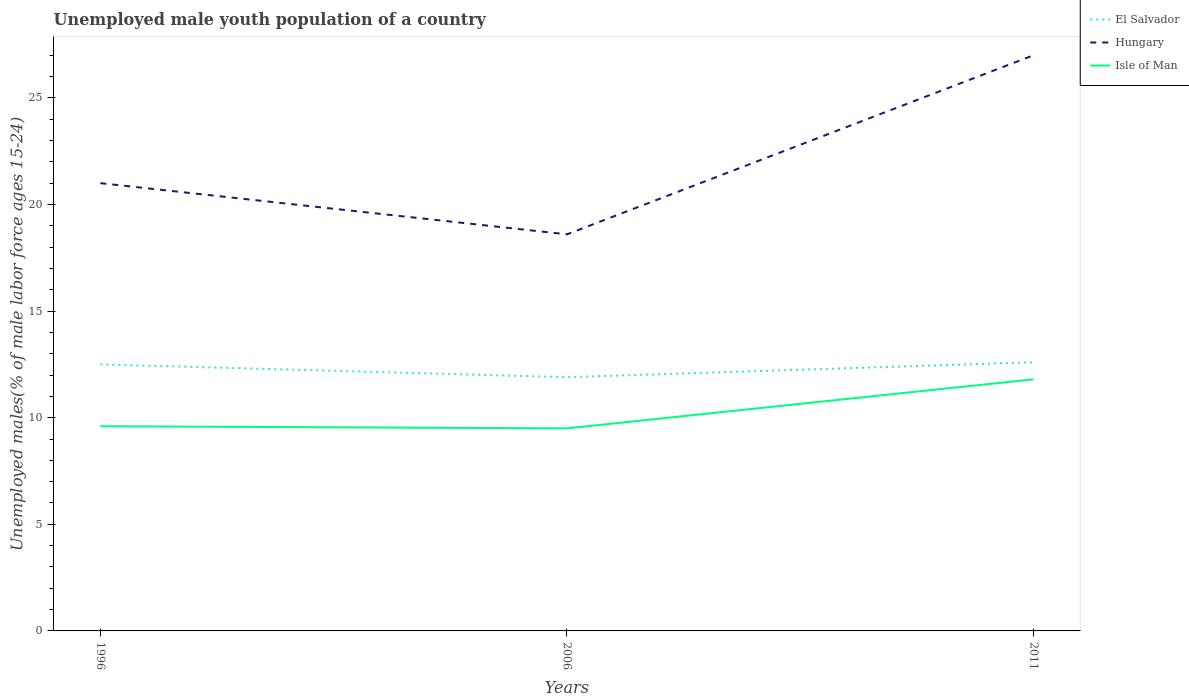Does the line corresponding to Isle of Man intersect with the line corresponding to Hungary?
Make the answer very short. No. Across all years, what is the maximum percentage of unemployed male youth population in El Salvador?
Your answer should be very brief. 11.9. What is the difference between the highest and the second highest percentage of unemployed male youth population in El Salvador?
Your answer should be very brief. 0.7. What is the difference between the highest and the lowest percentage of unemployed male youth population in Isle of Man?
Ensure brevity in your answer.  1. Is the percentage of unemployed male youth population in Hungary strictly greater than the percentage of unemployed male youth population in El Salvador over the years?
Keep it short and to the point. No. How many lines are there?
Offer a terse response. 3. Are the values on the major ticks of Y-axis written in scientific E-notation?
Make the answer very short. No. Does the graph contain any zero values?
Make the answer very short. No. Does the graph contain grids?
Your answer should be compact. No. How are the legend labels stacked?
Give a very brief answer. Vertical. What is the title of the graph?
Give a very brief answer. Unemployed male youth population of a country. Does "High income: nonOECD" appear as one of the legend labels in the graph?
Offer a terse response. No. What is the label or title of the X-axis?
Offer a very short reply. Years. What is the label or title of the Y-axis?
Offer a terse response. Unemployed males(% of male labor force ages 15-24). What is the Unemployed males(% of male labor force ages 15-24) of Hungary in 1996?
Provide a succinct answer. 21. What is the Unemployed males(% of male labor force ages 15-24) of Isle of Man in 1996?
Give a very brief answer. 9.6. What is the Unemployed males(% of male labor force ages 15-24) of El Salvador in 2006?
Provide a short and direct response. 11.9. What is the Unemployed males(% of male labor force ages 15-24) of Hungary in 2006?
Keep it short and to the point. 18.6. What is the Unemployed males(% of male labor force ages 15-24) of El Salvador in 2011?
Ensure brevity in your answer.  12.6. What is the Unemployed males(% of male labor force ages 15-24) of Hungary in 2011?
Offer a terse response. 27. What is the Unemployed males(% of male labor force ages 15-24) of Isle of Man in 2011?
Ensure brevity in your answer.  11.8. Across all years, what is the maximum Unemployed males(% of male labor force ages 15-24) in El Salvador?
Provide a short and direct response. 12.6. Across all years, what is the maximum Unemployed males(% of male labor force ages 15-24) of Isle of Man?
Give a very brief answer. 11.8. Across all years, what is the minimum Unemployed males(% of male labor force ages 15-24) in El Salvador?
Provide a succinct answer. 11.9. Across all years, what is the minimum Unemployed males(% of male labor force ages 15-24) in Hungary?
Offer a terse response. 18.6. What is the total Unemployed males(% of male labor force ages 15-24) of Hungary in the graph?
Give a very brief answer. 66.6. What is the total Unemployed males(% of male labor force ages 15-24) in Isle of Man in the graph?
Ensure brevity in your answer.  30.9. What is the difference between the Unemployed males(% of male labor force ages 15-24) of El Salvador in 1996 and that in 2006?
Provide a succinct answer. 0.6. What is the difference between the Unemployed males(% of male labor force ages 15-24) of Isle of Man in 1996 and that in 2006?
Give a very brief answer. 0.1. What is the difference between the Unemployed males(% of male labor force ages 15-24) in Hungary in 1996 and that in 2011?
Provide a succinct answer. -6. What is the difference between the Unemployed males(% of male labor force ages 15-24) in Isle of Man in 1996 and that in 2011?
Your answer should be very brief. -2.2. What is the difference between the Unemployed males(% of male labor force ages 15-24) of El Salvador in 2006 and that in 2011?
Give a very brief answer. -0.7. What is the difference between the Unemployed males(% of male labor force ages 15-24) in Isle of Man in 2006 and that in 2011?
Provide a succinct answer. -2.3. What is the difference between the Unemployed males(% of male labor force ages 15-24) of El Salvador in 1996 and the Unemployed males(% of male labor force ages 15-24) of Hungary in 2006?
Your answer should be very brief. -6.1. What is the difference between the Unemployed males(% of male labor force ages 15-24) of El Salvador in 1996 and the Unemployed males(% of male labor force ages 15-24) of Isle of Man in 2006?
Offer a terse response. 3. What is the difference between the Unemployed males(% of male labor force ages 15-24) of Hungary in 1996 and the Unemployed males(% of male labor force ages 15-24) of Isle of Man in 2006?
Your answer should be compact. 11.5. What is the difference between the Unemployed males(% of male labor force ages 15-24) of El Salvador in 1996 and the Unemployed males(% of male labor force ages 15-24) of Hungary in 2011?
Keep it short and to the point. -14.5. What is the difference between the Unemployed males(% of male labor force ages 15-24) of El Salvador in 2006 and the Unemployed males(% of male labor force ages 15-24) of Hungary in 2011?
Give a very brief answer. -15.1. What is the difference between the Unemployed males(% of male labor force ages 15-24) in El Salvador in 2006 and the Unemployed males(% of male labor force ages 15-24) in Isle of Man in 2011?
Your response must be concise. 0.1. What is the average Unemployed males(% of male labor force ages 15-24) in El Salvador per year?
Ensure brevity in your answer.  12.33. What is the average Unemployed males(% of male labor force ages 15-24) in Hungary per year?
Your response must be concise. 22.2. In the year 1996, what is the difference between the Unemployed males(% of male labor force ages 15-24) in El Salvador and Unemployed males(% of male labor force ages 15-24) in Hungary?
Your answer should be compact. -8.5. In the year 1996, what is the difference between the Unemployed males(% of male labor force ages 15-24) in Hungary and Unemployed males(% of male labor force ages 15-24) in Isle of Man?
Ensure brevity in your answer.  11.4. In the year 2011, what is the difference between the Unemployed males(% of male labor force ages 15-24) of El Salvador and Unemployed males(% of male labor force ages 15-24) of Hungary?
Your answer should be very brief. -14.4. What is the ratio of the Unemployed males(% of male labor force ages 15-24) in El Salvador in 1996 to that in 2006?
Provide a succinct answer. 1.05. What is the ratio of the Unemployed males(% of male labor force ages 15-24) in Hungary in 1996 to that in 2006?
Ensure brevity in your answer.  1.13. What is the ratio of the Unemployed males(% of male labor force ages 15-24) of Isle of Man in 1996 to that in 2006?
Keep it short and to the point. 1.01. What is the ratio of the Unemployed males(% of male labor force ages 15-24) in Hungary in 1996 to that in 2011?
Keep it short and to the point. 0.78. What is the ratio of the Unemployed males(% of male labor force ages 15-24) of Isle of Man in 1996 to that in 2011?
Keep it short and to the point. 0.81. What is the ratio of the Unemployed males(% of male labor force ages 15-24) in Hungary in 2006 to that in 2011?
Your response must be concise. 0.69. What is the ratio of the Unemployed males(% of male labor force ages 15-24) of Isle of Man in 2006 to that in 2011?
Offer a very short reply. 0.81. What is the difference between the highest and the lowest Unemployed males(% of male labor force ages 15-24) of El Salvador?
Your answer should be very brief. 0.7. What is the difference between the highest and the lowest Unemployed males(% of male labor force ages 15-24) of Hungary?
Your answer should be compact. 8.4. 